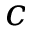Convert formula to latex. <formula><loc_0><loc_0><loc_500><loc_500>c</formula> 